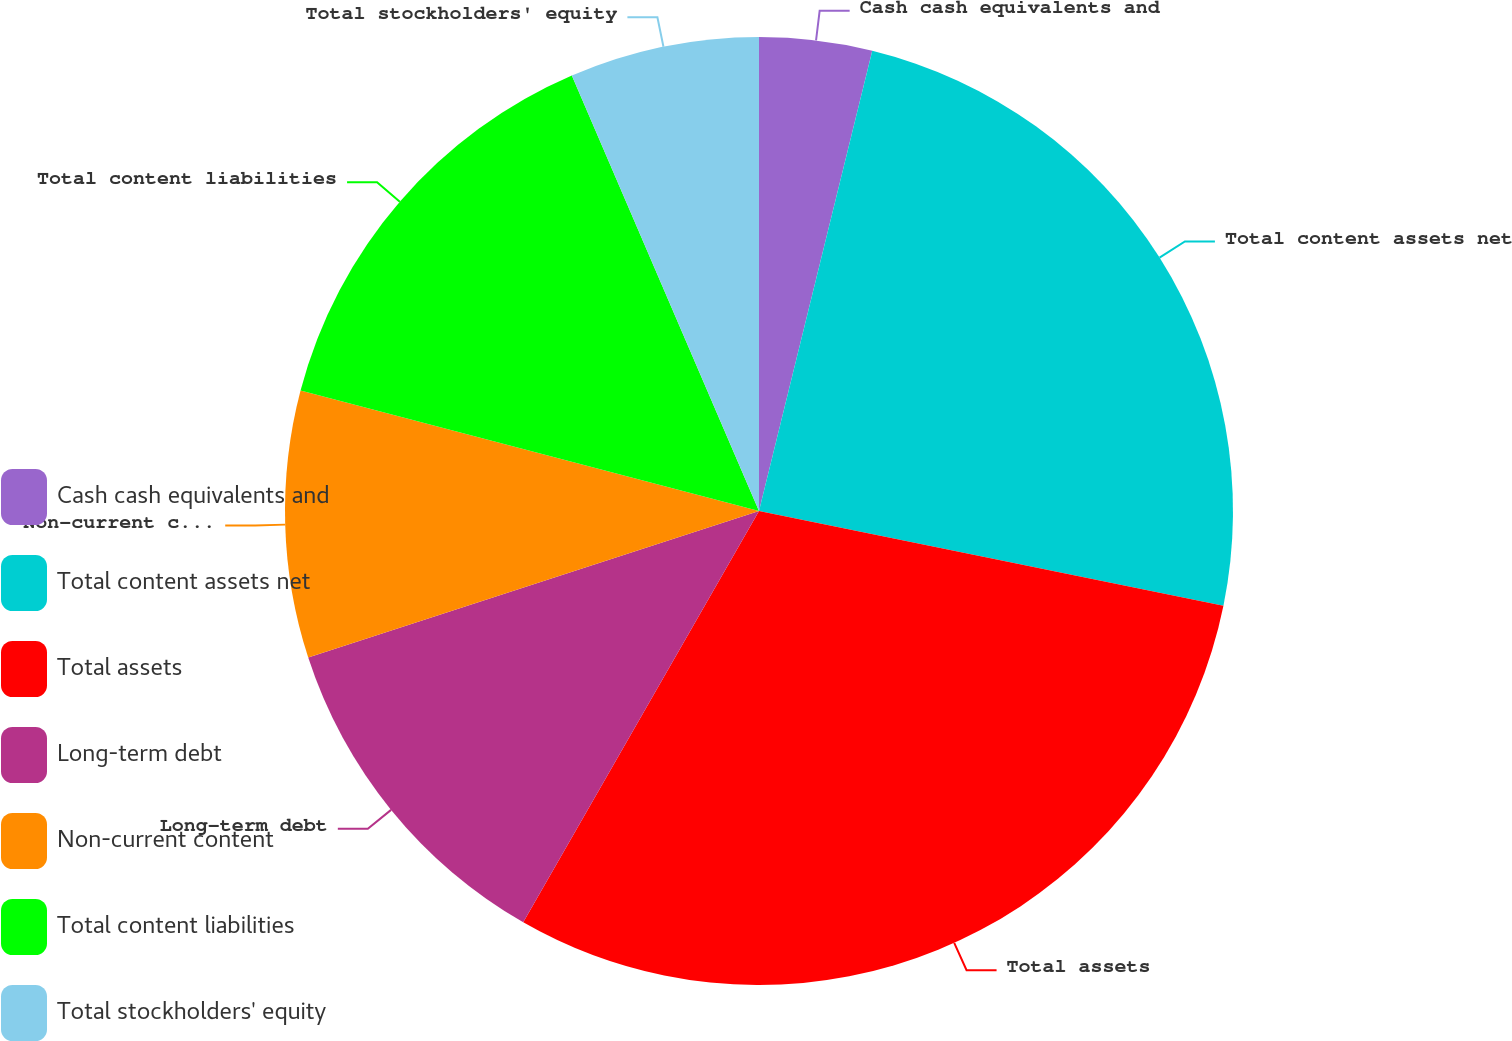Convert chart. <chart><loc_0><loc_0><loc_500><loc_500><pie_chart><fcel>Cash cash equivalents and<fcel>Total content assets net<fcel>Total assets<fcel>Long-term debt<fcel>Non-current content<fcel>Total content liabilities<fcel>Total stockholders' equity<nl><fcel>3.84%<fcel>24.36%<fcel>30.08%<fcel>11.71%<fcel>9.09%<fcel>14.45%<fcel>6.46%<nl></chart> 